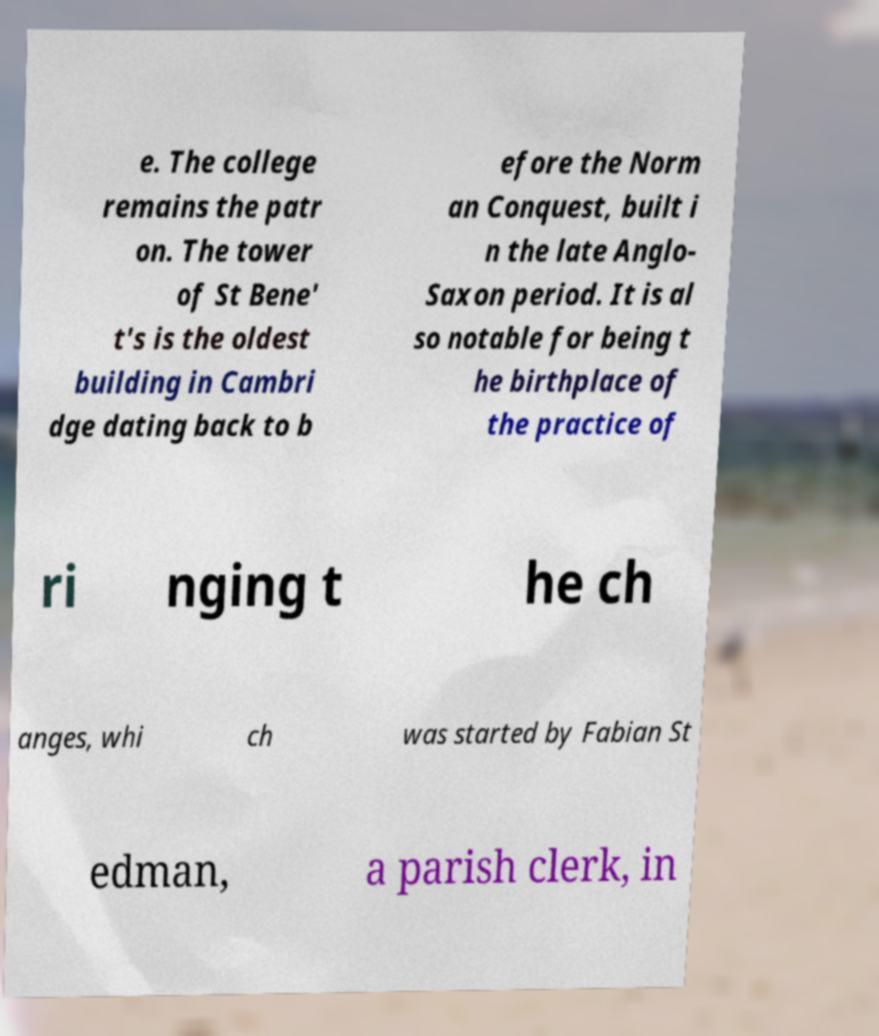There's text embedded in this image that I need extracted. Can you transcribe it verbatim? e. The college remains the patr on. The tower of St Bene' t's is the oldest building in Cambri dge dating back to b efore the Norm an Conquest, built i n the late Anglo- Saxon period. It is al so notable for being t he birthplace of the practice of ri nging t he ch anges, whi ch was started by Fabian St edman, a parish clerk, in 